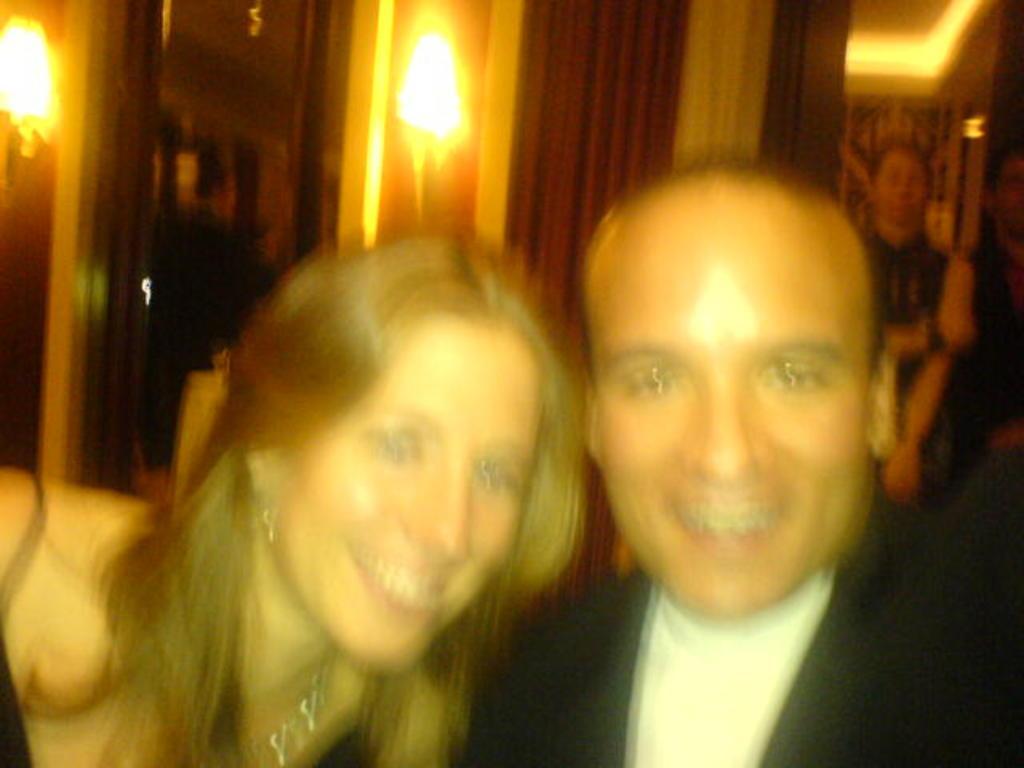In one or two sentences, can you explain what this image depicts? In this image there is a man towards the bottom of the image, there is a woman towards the bottom of the image, there are persons towards the right of the image, there is a wall towards the top of the image, there are lights on the wall, there is an object towards the top of the image that looks like a door, there is a curtain towards the top of the image, there is roof towards the top of the image. 